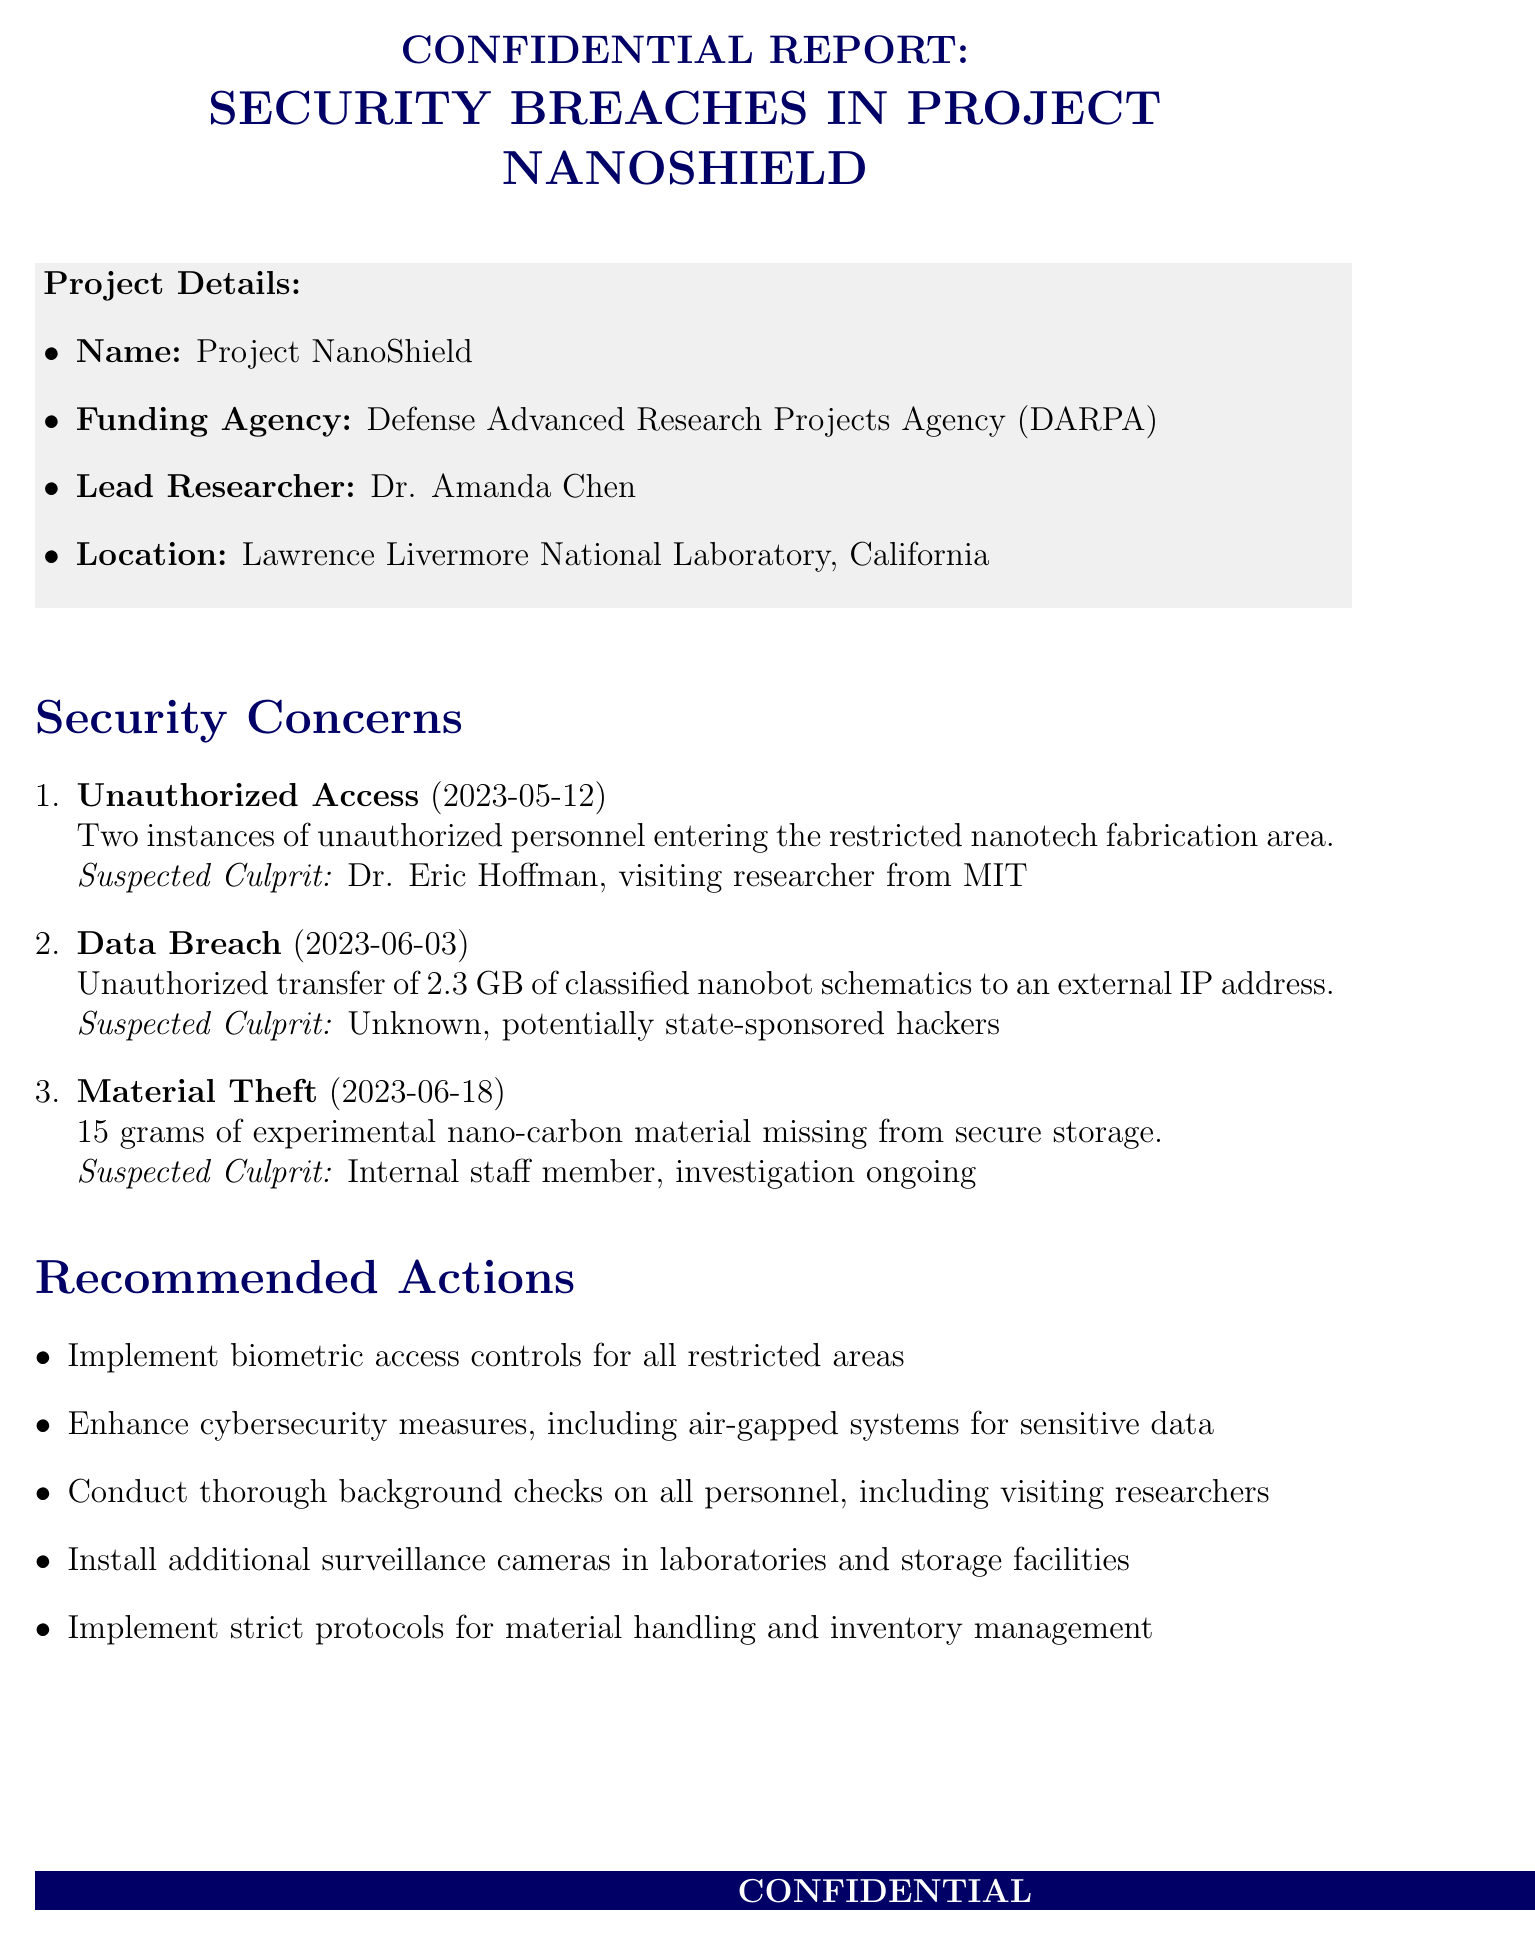What is the title of the report? The title of the report is specified in the document's header.
Answer: Confidential Report: Security Breaches in Project NanoShield Who is the lead researcher for Project NanoShield? The lead researcher is explicitly mentioned in the project details section of the document.
Answer: Dr. Amanda Chen What was stolen in the material theft incident? The document provides details on the type of material that went missing.
Answer: 15 grams of experimental nano-carbon material When did the data breach occur? The date of the data breach is clearly stated in the security concerns section.
Answer: 2023-06-03 What is one of the recommended actions regarding access control? The recommended actions section lists measures to strengthen security; one is about access controls.
Answer: Implement biometric access controls for all restricted areas What could be a potential consequence of the security breaches? Potential consequences are outlined in the document, highlighting risks associated with the breaches.
Answer: Compromise of national security if nanotech falls into wrong hands Which agency is suggested to be notified about these breaches? The agencies to notify section lists relevant agencies that should be informed.
Answer: Federal Bureau of Investigation (FBI) What is the location of Project NanoShield? The location is detailed in the project details part of the document.
Answer: Lawrence Livermore National Laboratory, California What will happen within 30 days according to the next steps? The next steps section outlines immediate actions to be taken following the discovery of security issues.
Answer: Implement new security protocols within 30 days 